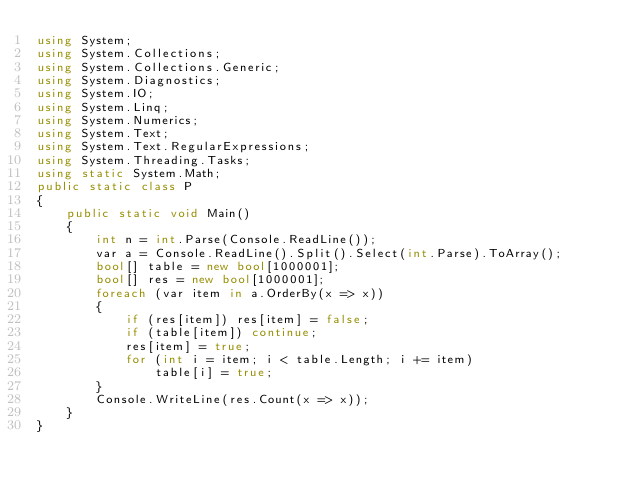Convert code to text. <code><loc_0><loc_0><loc_500><loc_500><_C#_>using System;
using System.Collections;
using System.Collections.Generic;
using System.Diagnostics;
using System.IO;
using System.Linq;
using System.Numerics;
using System.Text;
using System.Text.RegularExpressions;
using System.Threading.Tasks;
using static System.Math;
public static class P
{
    public static void Main()
    {
        int n = int.Parse(Console.ReadLine());
        var a = Console.ReadLine().Split().Select(int.Parse).ToArray();
        bool[] table = new bool[1000001];
        bool[] res = new bool[1000001];
        foreach (var item in a.OrderBy(x => x))
        {
            if (res[item]) res[item] = false;
            if (table[item]) continue;
            res[item] = true;
            for (int i = item; i < table.Length; i += item)
                table[i] = true;
        }
        Console.WriteLine(res.Count(x => x));
    }
}</code> 